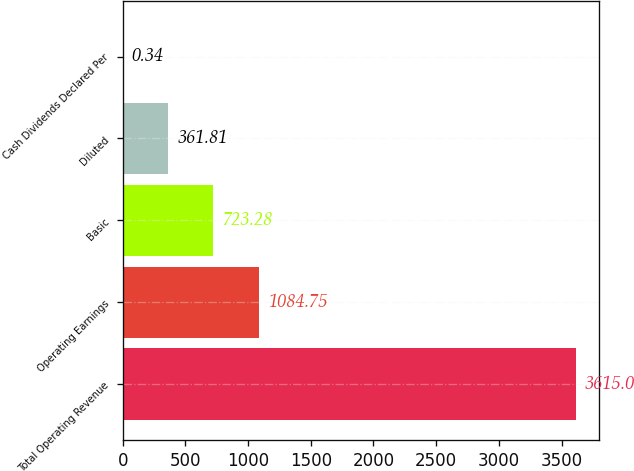Convert chart. <chart><loc_0><loc_0><loc_500><loc_500><bar_chart><fcel>Total Operating Revenue<fcel>Operating Earnings<fcel>Basic<fcel>Diluted<fcel>Cash Dividends Declared Per<nl><fcel>3615<fcel>1084.75<fcel>723.28<fcel>361.81<fcel>0.34<nl></chart> 